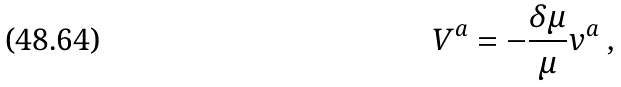<formula> <loc_0><loc_0><loc_500><loc_500>V ^ { a } = - \frac { \delta \mu } { \mu } v ^ { a } \ ,</formula> 